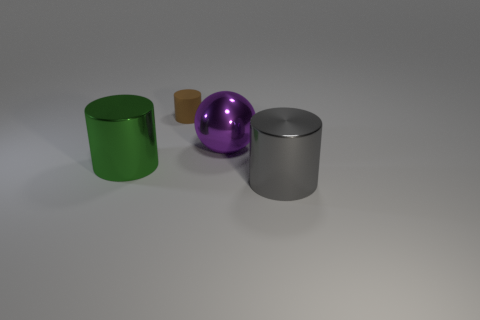What number of other things are there of the same color as the tiny object?
Offer a terse response. 0. Is there anything else that has the same shape as the large purple shiny object?
Provide a succinct answer. No. There is a shiny cylinder that is right of the green metal object; is it the same size as the big purple metal thing?
Offer a very short reply. Yes. How many matte objects are tiny things or red things?
Provide a succinct answer. 1. There is a metallic cylinder that is behind the big gray cylinder; what is its size?
Provide a short and direct response. Large. Do the brown object and the big gray thing have the same shape?
Offer a very short reply. Yes. How many tiny things are either brown objects or cyan balls?
Give a very brief answer. 1. There is a small brown cylinder; are there any tiny brown things behind it?
Provide a short and direct response. No. Are there an equal number of big purple objects behind the large ball and big yellow rubber things?
Ensure brevity in your answer.  Yes. There is a gray shiny object that is the same shape as the brown rubber thing; what is its size?
Give a very brief answer. Large. 